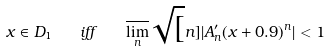Convert formula to latex. <formula><loc_0><loc_0><loc_500><loc_500>x \in D _ { 1 } \quad i f f \quad \overline { \lim _ { n } } \sqrt { [ } n ] { | A ^ { \prime } _ { n } ( x + 0 . 9 ) ^ { n } | } < 1</formula> 